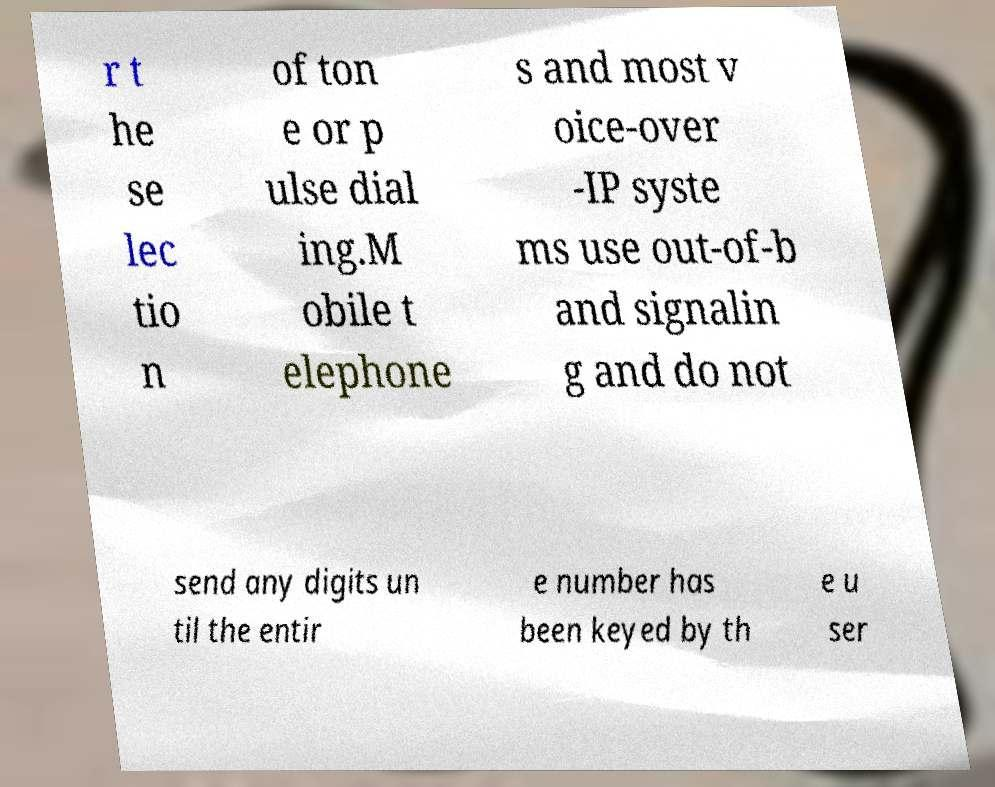For documentation purposes, I need the text within this image transcribed. Could you provide that? r t he se lec tio n of ton e or p ulse dial ing.M obile t elephone s and most v oice-over -IP syste ms use out-of-b and signalin g and do not send any digits un til the entir e number has been keyed by th e u ser 